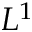<formula> <loc_0><loc_0><loc_500><loc_500>L ^ { 1 }</formula> 